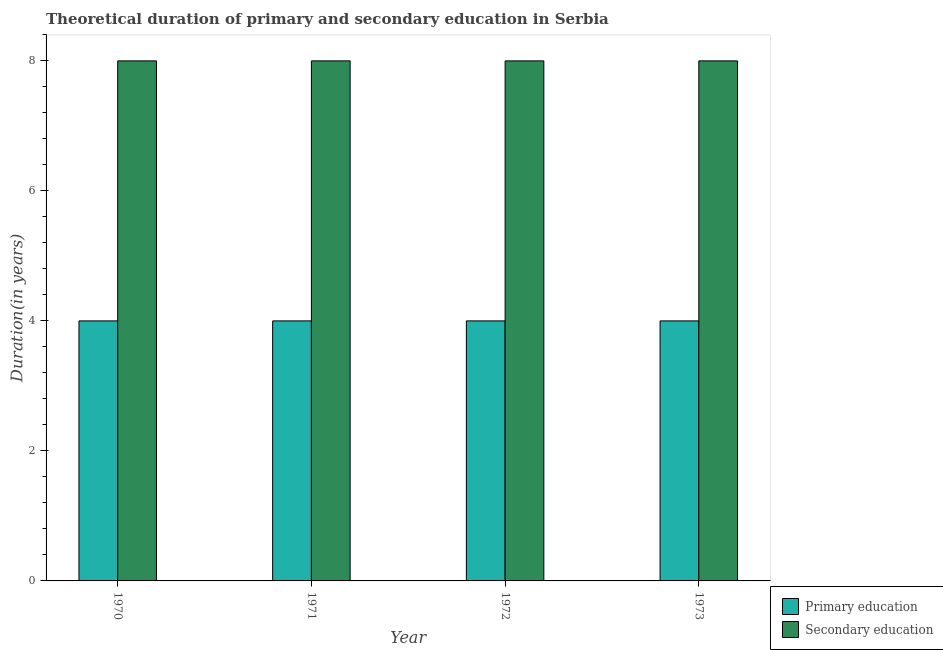How many different coloured bars are there?
Make the answer very short. 2. Are the number of bars on each tick of the X-axis equal?
Provide a succinct answer. Yes. In how many cases, is the number of bars for a given year not equal to the number of legend labels?
Your answer should be compact. 0. What is the duration of primary education in 1971?
Ensure brevity in your answer.  4. Across all years, what is the maximum duration of secondary education?
Your response must be concise. 8. Across all years, what is the minimum duration of secondary education?
Keep it short and to the point. 8. In which year was the duration of primary education maximum?
Your answer should be compact. 1970. What is the total duration of primary education in the graph?
Offer a very short reply. 16. What is the difference between the duration of primary education in 1970 and that in 1973?
Ensure brevity in your answer.  0. What is the average duration of secondary education per year?
Your answer should be compact. 8. In the year 1972, what is the difference between the duration of secondary education and duration of primary education?
Your answer should be very brief. 0. What is the ratio of the duration of secondary education in 1970 to that in 1971?
Offer a terse response. 1. What is the difference between the highest and the lowest duration of secondary education?
Make the answer very short. 0. In how many years, is the duration of secondary education greater than the average duration of secondary education taken over all years?
Make the answer very short. 0. Is the sum of the duration of secondary education in 1971 and 1973 greater than the maximum duration of primary education across all years?
Your response must be concise. Yes. What does the 2nd bar from the left in 1970 represents?
Your answer should be very brief. Secondary education. What does the 1st bar from the right in 1971 represents?
Provide a short and direct response. Secondary education. How many bars are there?
Make the answer very short. 8. What is the difference between two consecutive major ticks on the Y-axis?
Ensure brevity in your answer.  2. Does the graph contain any zero values?
Offer a terse response. No. Does the graph contain grids?
Provide a short and direct response. No. Where does the legend appear in the graph?
Offer a very short reply. Bottom right. How many legend labels are there?
Keep it short and to the point. 2. How are the legend labels stacked?
Keep it short and to the point. Vertical. What is the title of the graph?
Provide a succinct answer. Theoretical duration of primary and secondary education in Serbia. Does "Urban" appear as one of the legend labels in the graph?
Your answer should be compact. No. What is the label or title of the Y-axis?
Ensure brevity in your answer.  Duration(in years). What is the Duration(in years) of Secondary education in 1970?
Your answer should be very brief. 8. What is the Duration(in years) in Primary education in 1971?
Offer a terse response. 4. What is the Duration(in years) of Primary education in 1972?
Provide a succinct answer. 4. Across all years, what is the maximum Duration(in years) of Primary education?
Offer a very short reply. 4. Across all years, what is the maximum Duration(in years) of Secondary education?
Ensure brevity in your answer.  8. Across all years, what is the minimum Duration(in years) of Primary education?
Your answer should be compact. 4. What is the total Duration(in years) in Primary education in the graph?
Your response must be concise. 16. What is the total Duration(in years) in Secondary education in the graph?
Offer a very short reply. 32. What is the difference between the Duration(in years) of Primary education in 1970 and that in 1972?
Offer a very short reply. 0. What is the difference between the Duration(in years) of Secondary education in 1970 and that in 1973?
Provide a short and direct response. 0. What is the difference between the Duration(in years) in Secondary education in 1971 and that in 1973?
Provide a succinct answer. 0. What is the difference between the Duration(in years) in Primary education in 1972 and that in 1973?
Give a very brief answer. 0. What is the difference between the Duration(in years) of Secondary education in 1972 and that in 1973?
Provide a succinct answer. 0. What is the difference between the Duration(in years) of Primary education in 1970 and the Duration(in years) of Secondary education in 1973?
Your response must be concise. -4. What is the difference between the Duration(in years) in Primary education in 1971 and the Duration(in years) in Secondary education in 1972?
Offer a terse response. -4. What is the difference between the Duration(in years) of Primary education in 1972 and the Duration(in years) of Secondary education in 1973?
Your answer should be very brief. -4. What is the ratio of the Duration(in years) in Secondary education in 1970 to that in 1971?
Ensure brevity in your answer.  1. What is the ratio of the Duration(in years) in Primary education in 1970 to that in 1972?
Your answer should be compact. 1. What is the ratio of the Duration(in years) in Secondary education in 1970 to that in 1972?
Provide a succinct answer. 1. What is the ratio of the Duration(in years) of Secondary education in 1970 to that in 1973?
Your answer should be very brief. 1. What is the ratio of the Duration(in years) of Secondary education in 1971 to that in 1972?
Your answer should be very brief. 1. What is the ratio of the Duration(in years) of Primary education in 1972 to that in 1973?
Make the answer very short. 1. What is the difference between the highest and the second highest Duration(in years) of Secondary education?
Provide a short and direct response. 0. What is the difference between the highest and the lowest Duration(in years) in Primary education?
Make the answer very short. 0. What is the difference between the highest and the lowest Duration(in years) in Secondary education?
Ensure brevity in your answer.  0. 